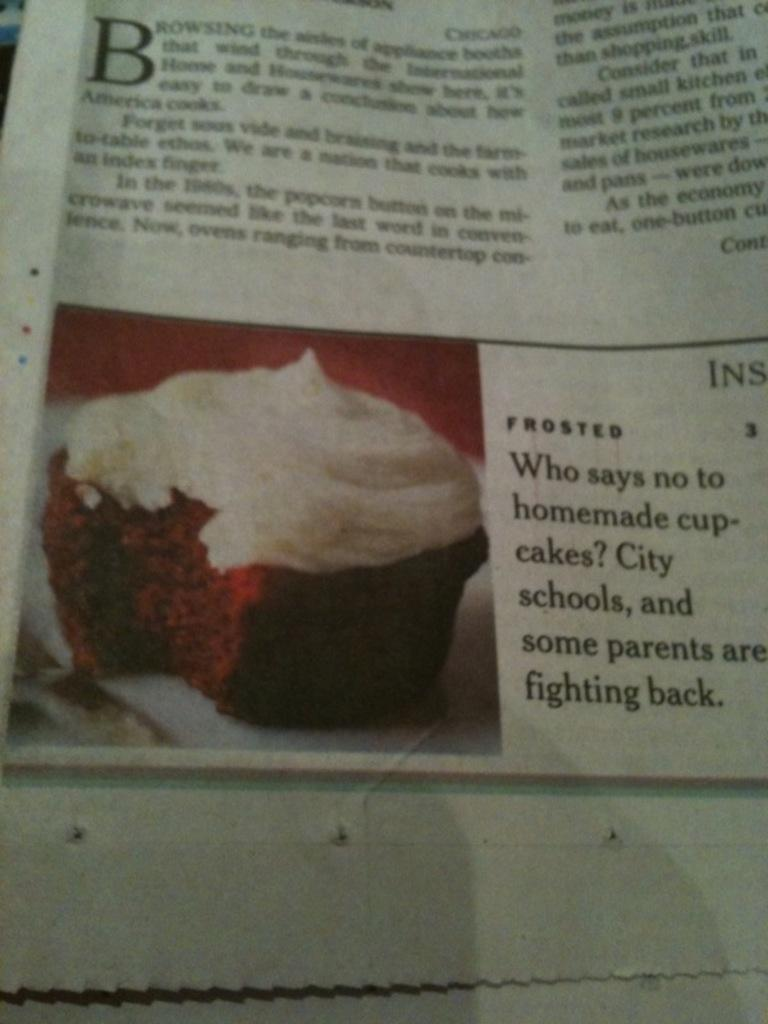<image>
Render a clear and concise summary of the photo. A newspaper article asking who would say no to homemade cupcakes 